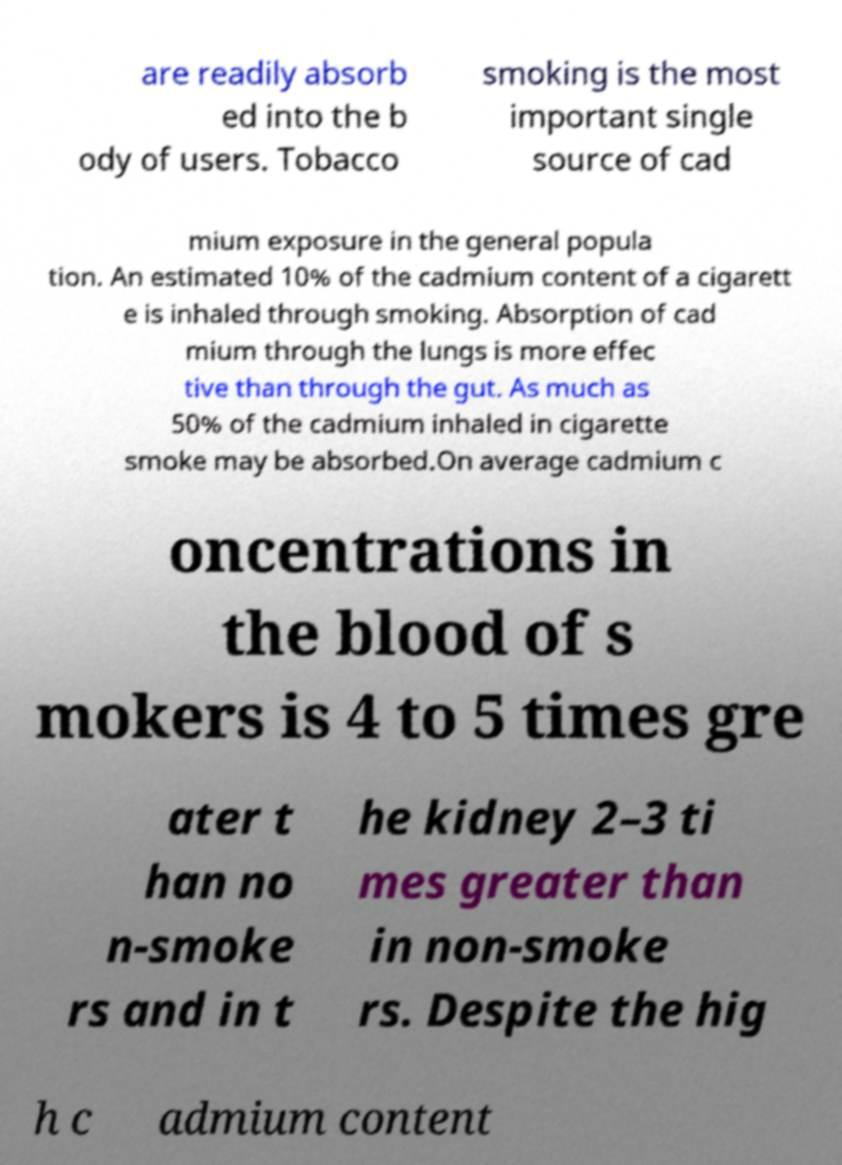For documentation purposes, I need the text within this image transcribed. Could you provide that? are readily absorb ed into the b ody of users. Tobacco smoking is the most important single source of cad mium exposure in the general popula tion. An estimated 10% of the cadmium content of a cigarett e is inhaled through smoking. Absorption of cad mium through the lungs is more effec tive than through the gut. As much as 50% of the cadmium inhaled in cigarette smoke may be absorbed.On average cadmium c oncentrations in the blood of s mokers is 4 to 5 times gre ater t han no n-smoke rs and in t he kidney 2–3 ti mes greater than in non-smoke rs. Despite the hig h c admium content 